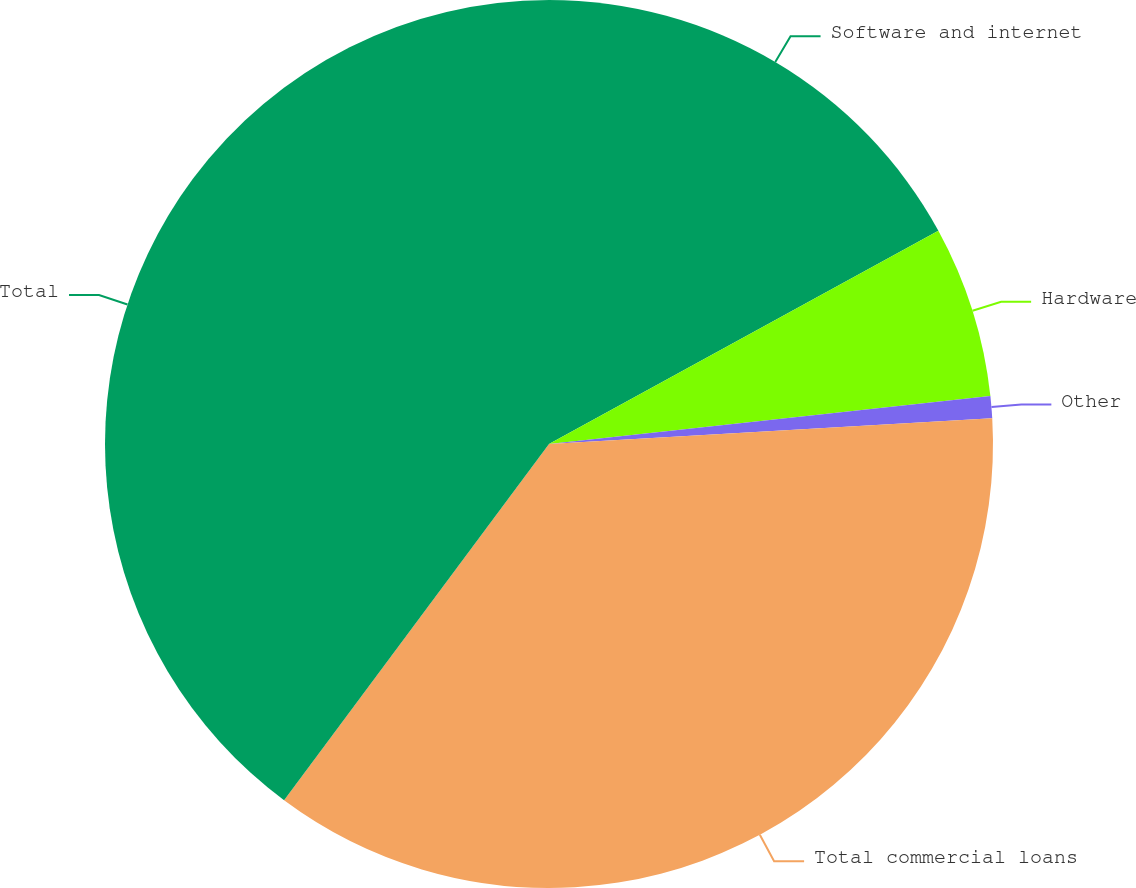<chart> <loc_0><loc_0><loc_500><loc_500><pie_chart><fcel>Software and internet<fcel>Hardware<fcel>Other<fcel>Total commercial loans<fcel>Total<nl><fcel>17.02%<fcel>6.25%<fcel>0.8%<fcel>36.1%<fcel>39.82%<nl></chart> 